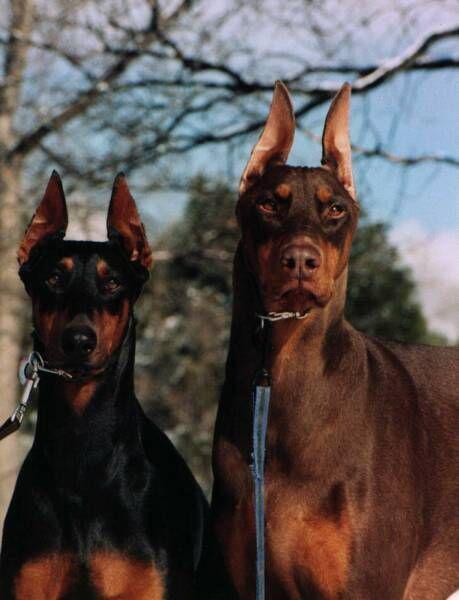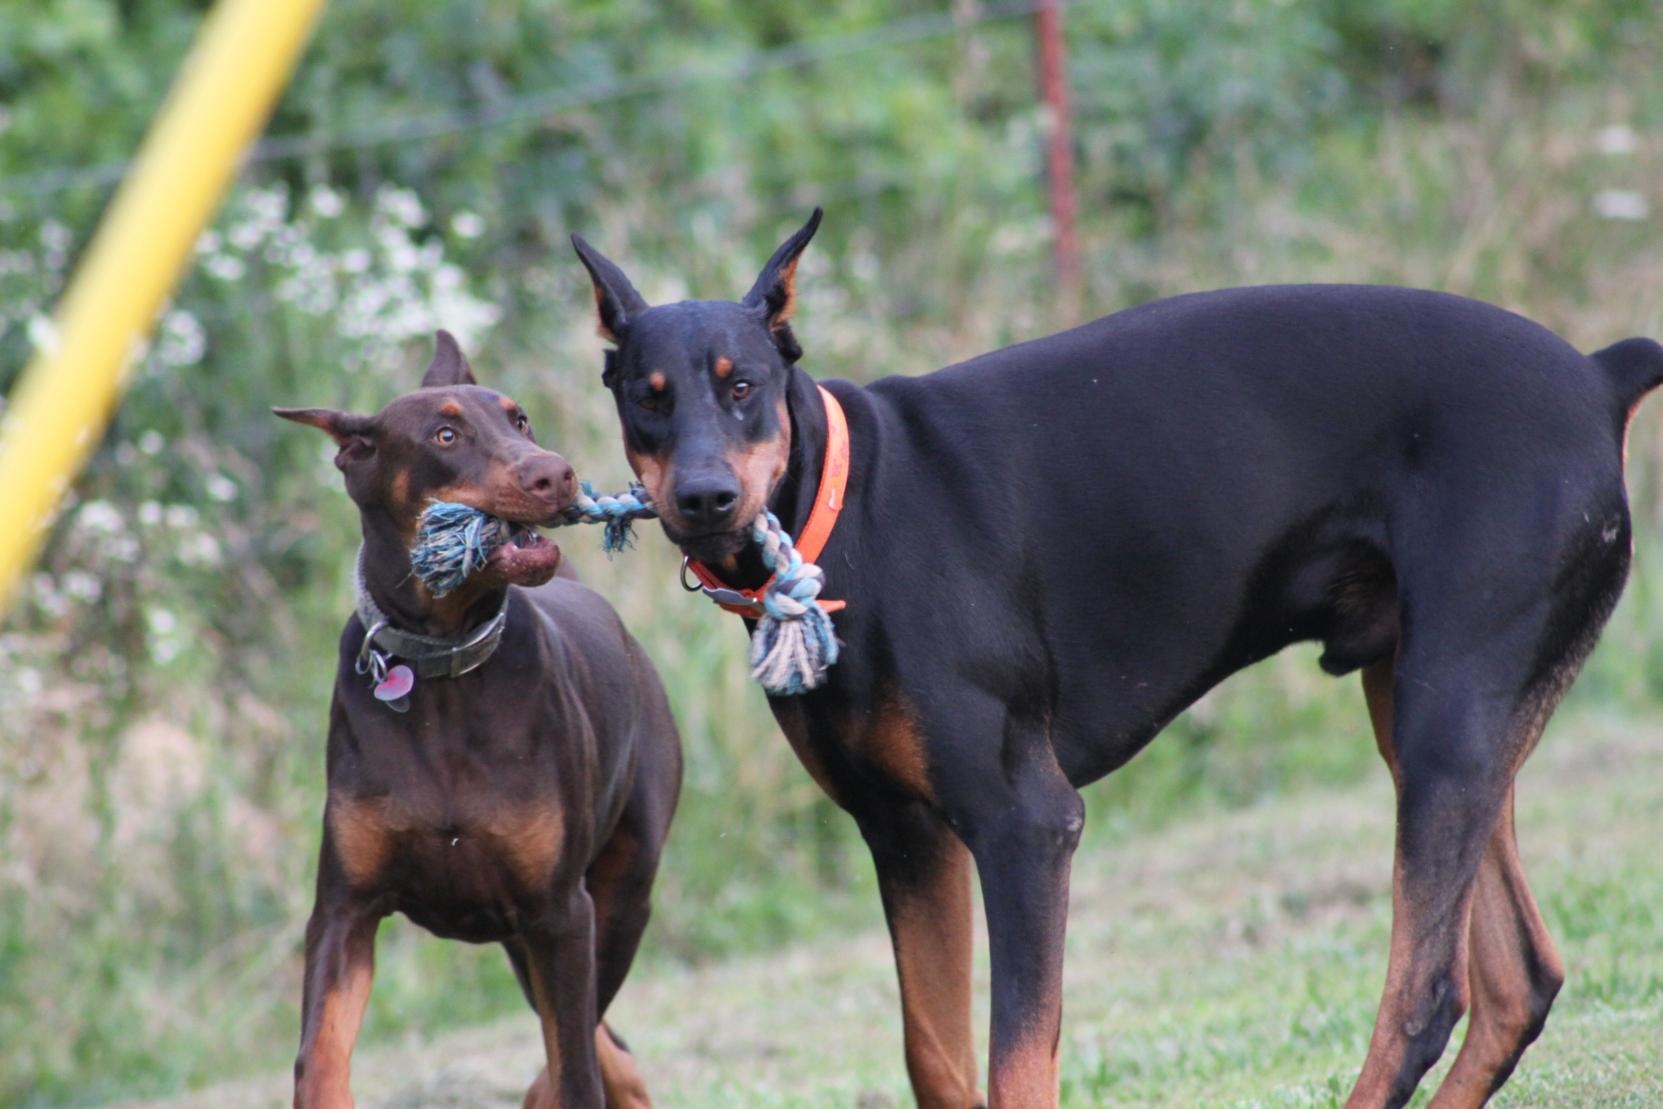The first image is the image on the left, the second image is the image on the right. Considering the images on both sides, is "The right image contains exactly two dogs." valid? Answer yes or no. Yes. The first image is the image on the left, the second image is the image on the right. Evaluate the accuracy of this statement regarding the images: "The left image shows two forward-turned dobermans with pointy ears and collars posed side-by-side, and the right image shows two dobermans interacting with their noses close together.". Is it true? Answer yes or no. Yes. 